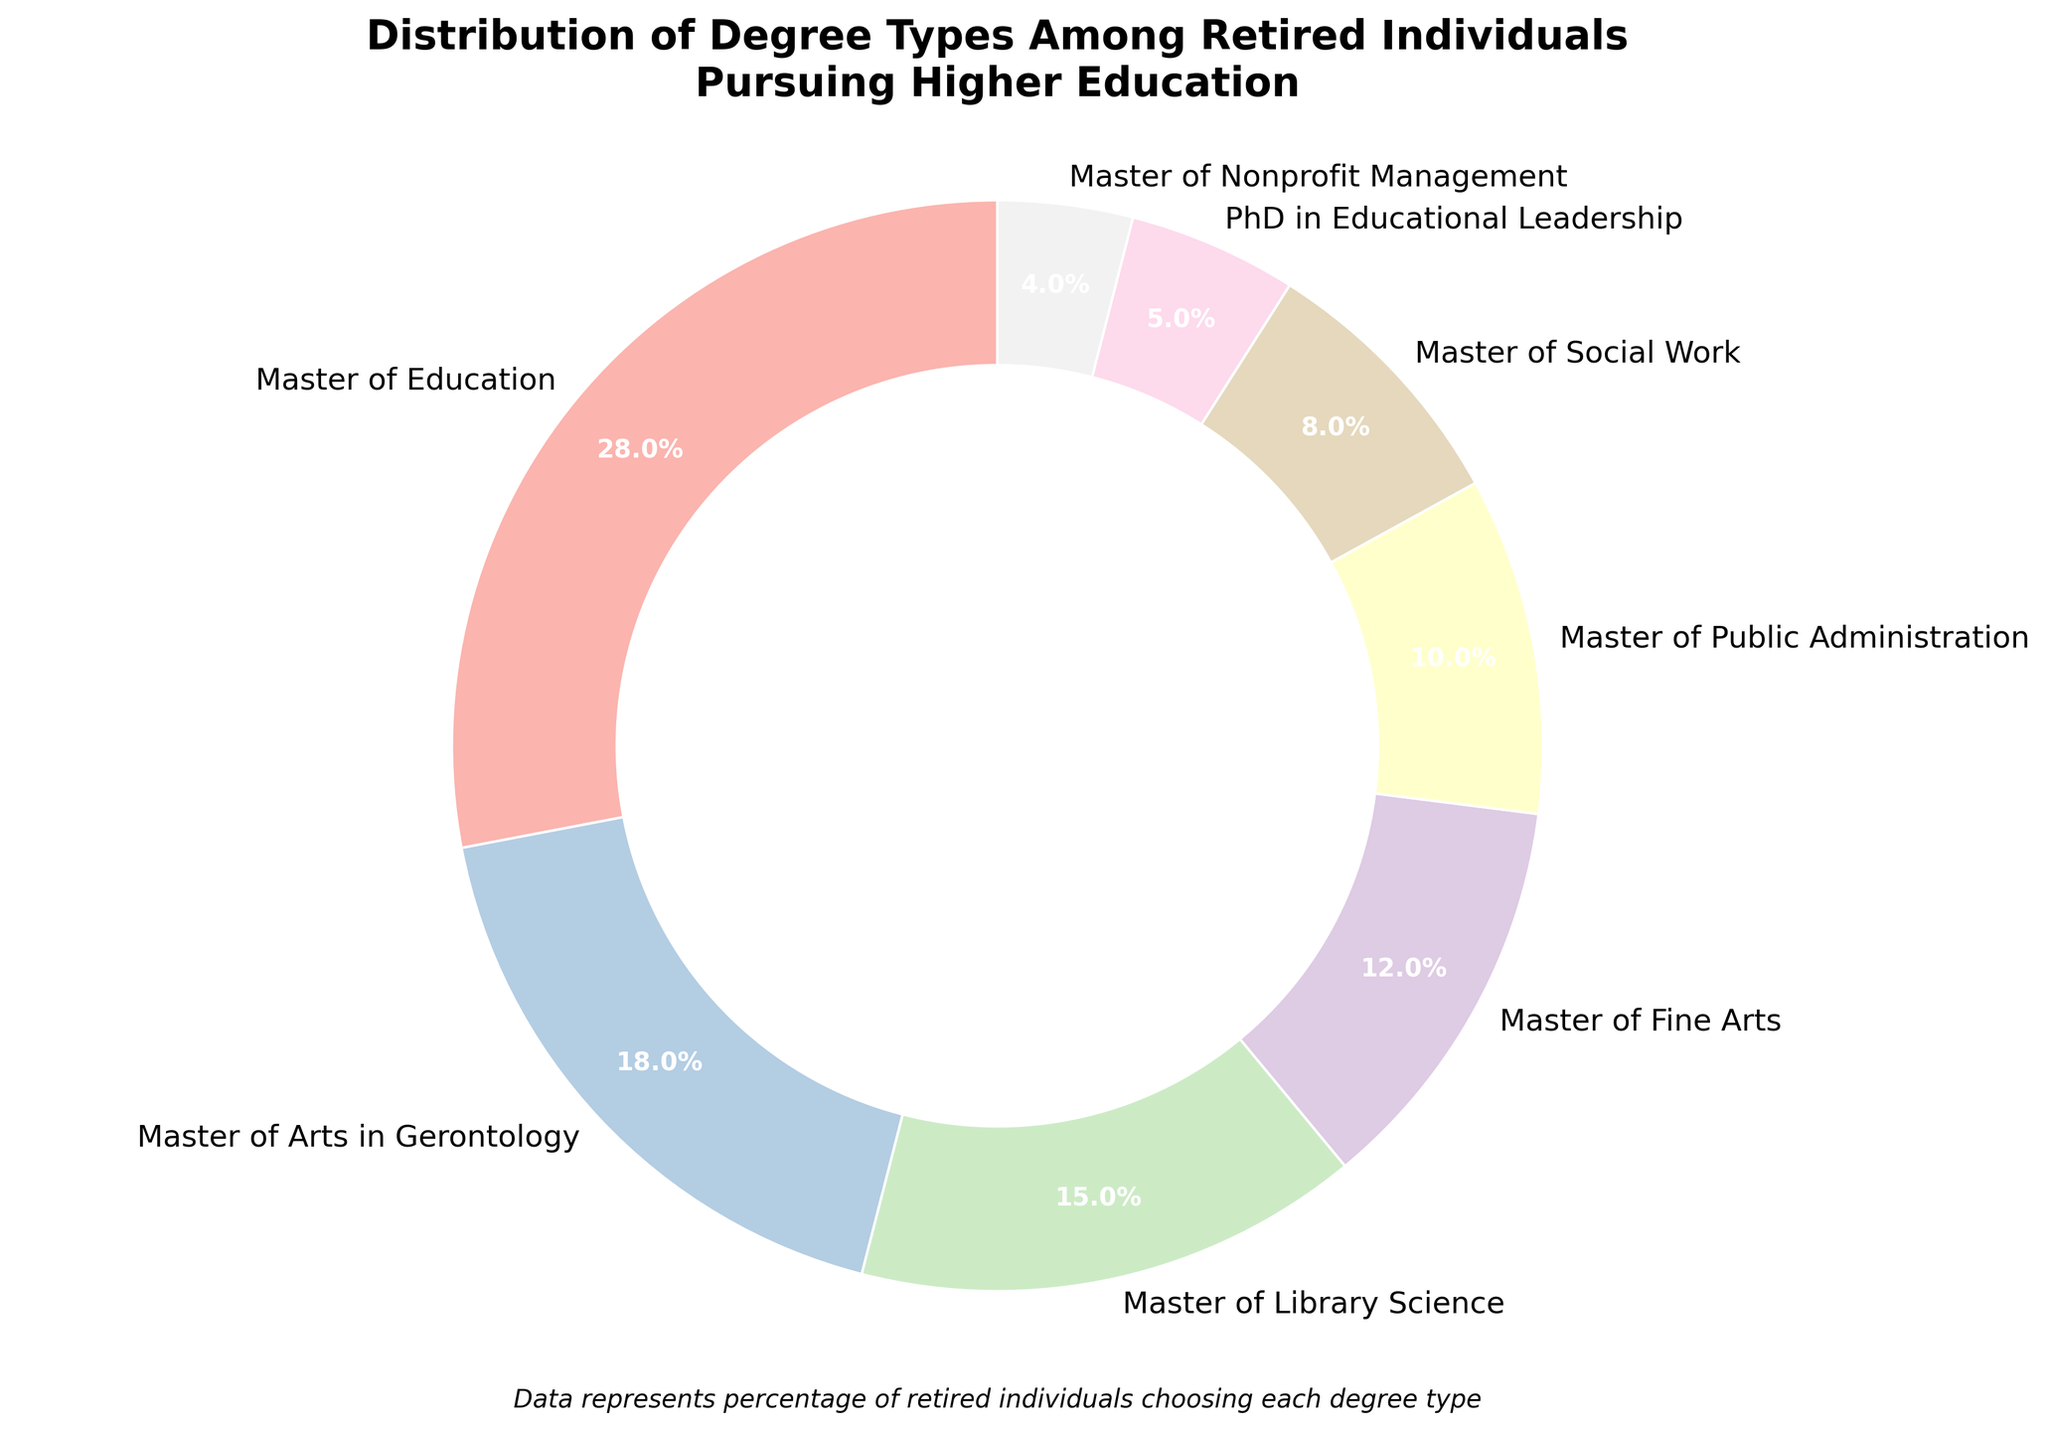What degree type has the largest percentage of retired individuals pursuing higher education? First, look at the categories and their associated percentages. The category with the largest percentage is "Master of Education" with 28%.
Answer: Master of Education Which degree type has the smallest percentage of retired individuals? Look for the degree type with the lowest percentage in the chart. The smallest percentage is 4%, which corresponds to "Master of Nonprofit Management".
Answer: Master of Nonprofit Management What is the combined percentage of retired individuals pursuing Master of Fine Arts and Master of Public Administration degrees? Add the percentages of "Master of Fine Arts (12%)" and "Master of Public Administration (10%)". So, 12% + 10% = 22%.
Answer: 22% Is the percentage of individuals pursuing a Master of Library Science more than twice the percentage of those pursuing a PhD in Educational Leadership? The percentage for "Master of Library Science" is 15%, and for "PhD in Educational Leadership" is 5%. Compare if 15% is more than twice 5%. Twice 5% is 10%, and since 15% > 10%, the answer is yes.
Answer: Yes Which degree types constitute exactly half of the pie chart? The percentages to consider are "28% (Master of Education)" and "18% (Master of Arts in Gerontology)", which sum up to 46%, which is not half. The correct combination is "Master of Education (28%)" and "Master of Library Science (15%)", which sum to 43%, still less than half. Finally, "Master of Fine Arts (12%)" and "Master of Public Administration (10%)" coming up with "Master of Education (28%)" give 50%.
Answer: Master of Education, Master of Arts in Gerontology, and Master of Library Science How much more popular is the Master of Education degree than the Master of Social Work degree among retired individuals? Subtract the percentage of "Master of Social Work (8%)" from the percentage of "Master of Education (28%)". 28% - 8% = 20%.
Answer: 20% Are there more retired individuals pursuing degrees in Public Administration or in Gerontology? Compare the percentages for "Master of Public Administration (10%)" and "Master of Arts in Gerontology (18%)". Since 18% > 10%, more individuals pursue degrees in Gerontology.
Answer: Gerontology What is the total percentage of individuals pursuing degrees in Library Science, Social Work, and Nonprofit Management? Add the percentages: "Master of Library Science (15%)", "Master of Social Work (8%)", and "Master of Nonprofit Management (4%)". So, 15% + 8% + 4% = 27%.
Answer: 27% What is the difference between the percentage of individuals pursuing Master of Public Administration and PhD in Educational Leadership degrees? Subtract the percentage of "PhD in Educational Leadership (5%)" from "Master of Public Administration (10%)". 10% - 5% = 5%.
Answer: 5% Does the combined percentage of individuals pursuing Master of Fine Arts and PhD in Educational Leadership degrees exceed the percentage of those pursuing Master of Education degrees? Add the percentages of "Master of Fine Arts (12%)" and "PhD in Educational Leadership (5%)". 12% + 5% = 17%, which is less than 28% for "Master of Education".
Answer: No 